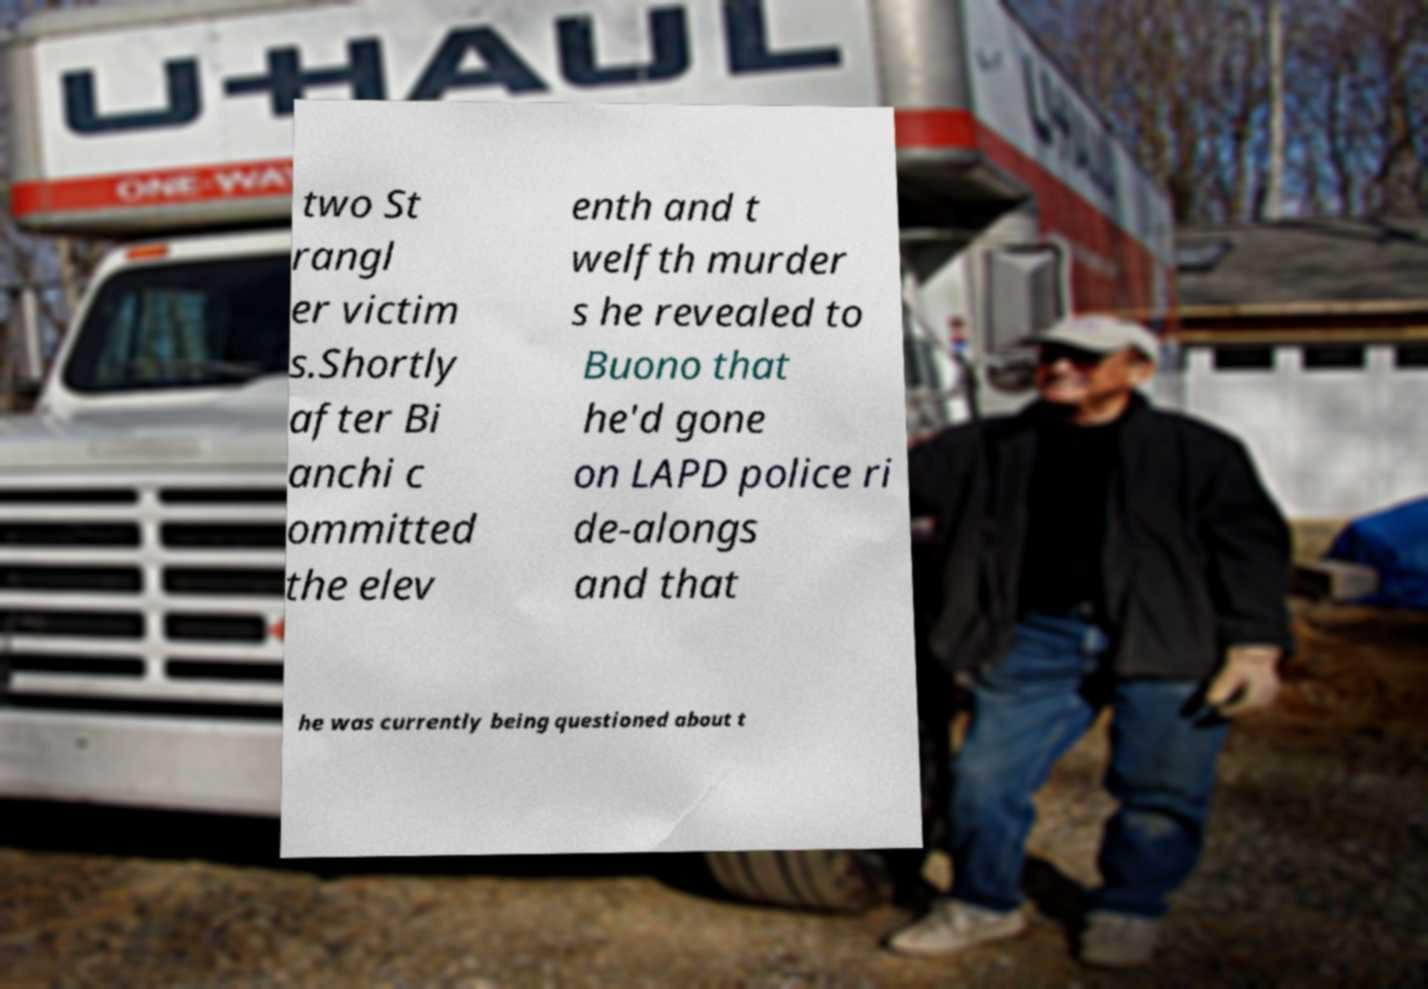For documentation purposes, I need the text within this image transcribed. Could you provide that? two St rangl er victim s.Shortly after Bi anchi c ommitted the elev enth and t welfth murder s he revealed to Buono that he'd gone on LAPD police ri de-alongs and that he was currently being questioned about t 